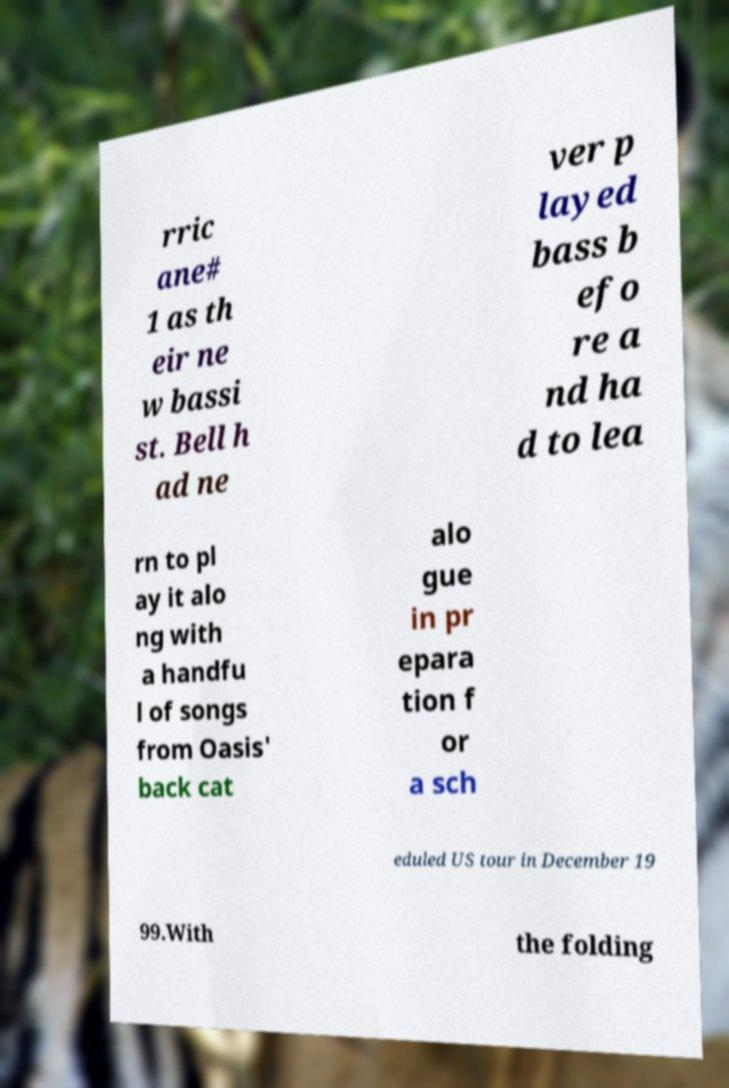Can you read and provide the text displayed in the image?This photo seems to have some interesting text. Can you extract and type it out for me? rric ane# 1 as th eir ne w bassi st. Bell h ad ne ver p layed bass b efo re a nd ha d to lea rn to pl ay it alo ng with a handfu l of songs from Oasis' back cat alo gue in pr epara tion f or a sch eduled US tour in December 19 99.With the folding 